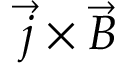Convert formula to latex. <formula><loc_0><loc_0><loc_500><loc_500>{ \vec { j } } \times { \vec { B } }</formula> 